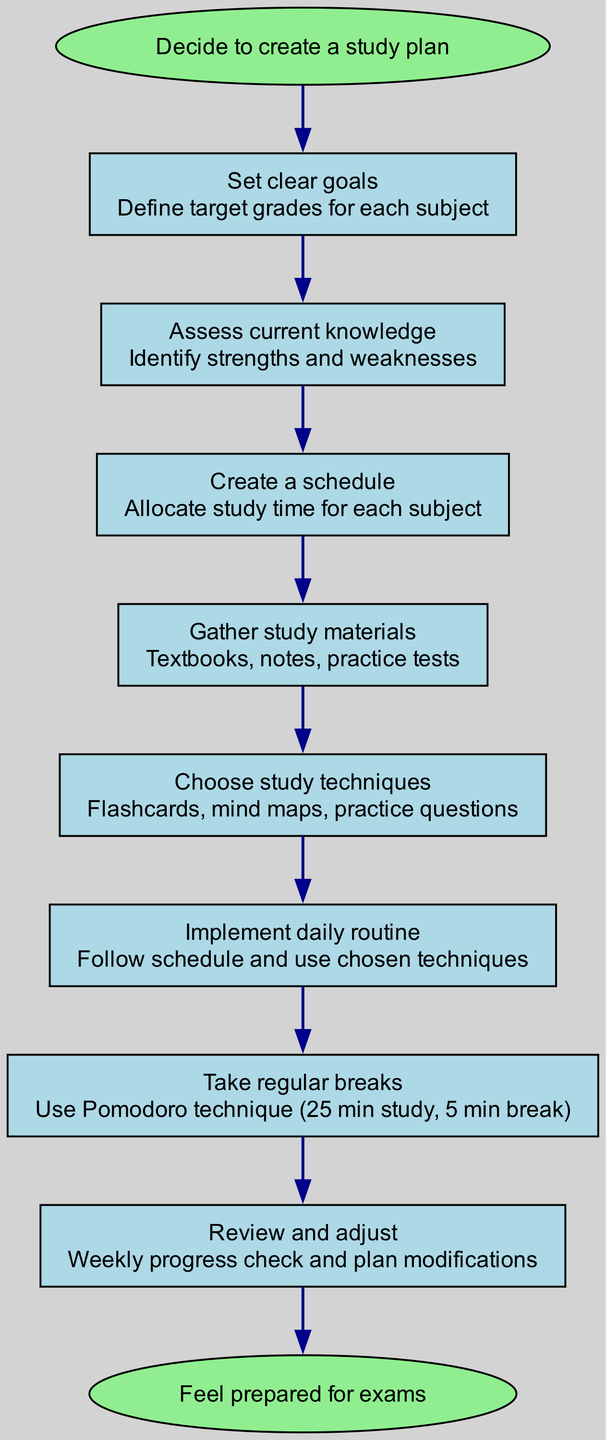What is the starting point of the flow chart? The starting point is identified as "Decide to create a study plan." It is the first node in the diagram, which is described as the entry into the flow.
Answer: Decide to create a study plan How many steps are there in the study plan? By counting the individual steps listed in the diagram, there are eight distinct steps outlined for creating the study plan.
Answer: 8 What step comes after "Assess current knowledge"? The step that follows "Assess current knowledge" according to the flow order is "Create a schedule." This is determined by examining the flow from one node to the next in the sequence.
Answer: Create a schedule Which study technique is mentioned in the flow chart? The diagram specifies several study techniques, including "Flashcards, mind maps, practice questions." These are listed within the step that discusses choosing study techniques.
Answer: Flashcards, mind maps, practice questions What does the "Review and adjust" step entail? The "Review and adjust" step includes "Weekly progress check and plan modifications." This information is derived from the details connected to that specific step in the diagram.
Answer: Weekly progress check and plan modifications How does the flow connect from "Gather study materials" to the next step? The flow connects from "Gather study materials" directly to "Choose study techniques," indicating a sequential progression where one step leads directly to the next without any divergence.
Answer: Choose study techniques What is the ending point of the flow chart? The ending point is defined as "Feel prepared for exams." This is the final node that concludes the steps outlined in the diagram, representing the desired outcome.
Answer: Feel prepared for exams Is there a step that involves taking breaks? Yes, the diagram includes a step explicitly labeled "Take regular breaks," and it details the use of the Pomodoro technique for structuring these breaks within the study plan.
Answer: Take regular breaks 